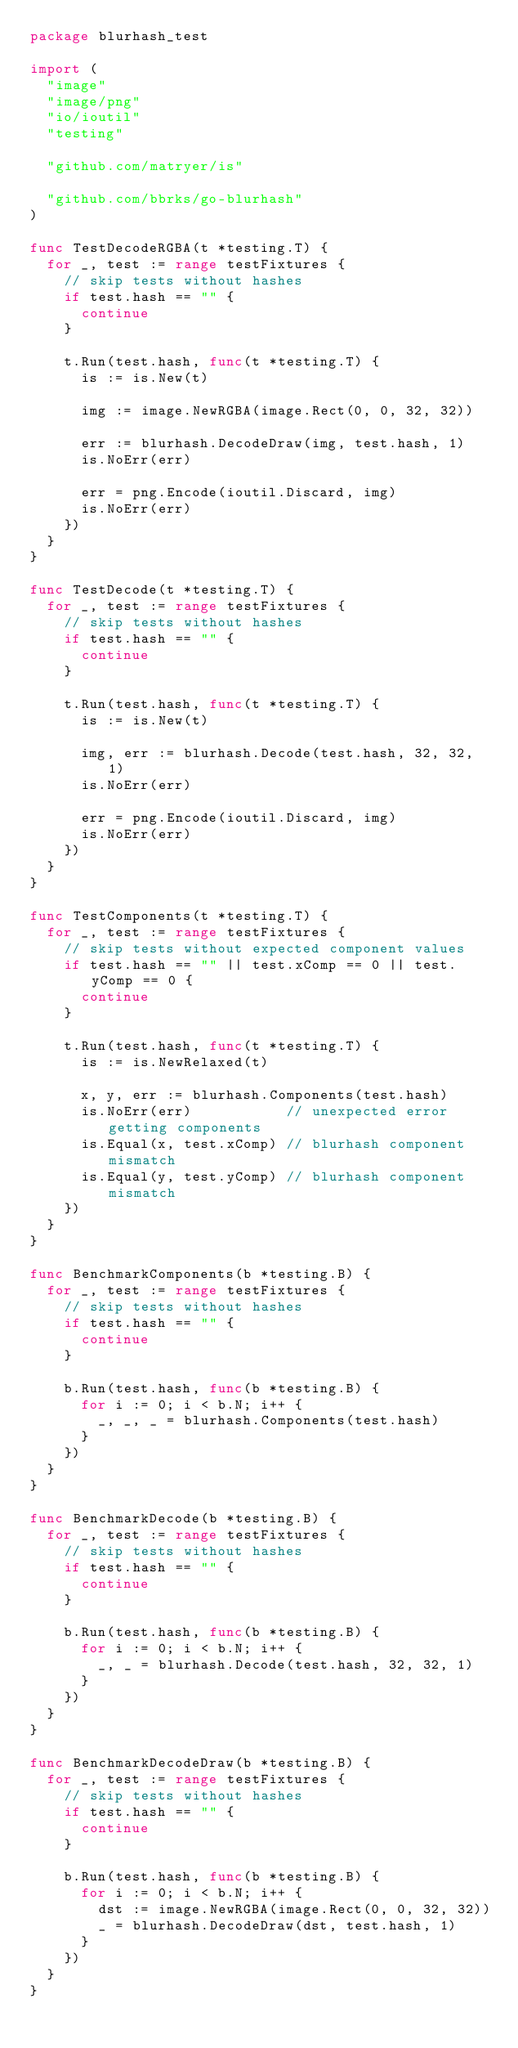<code> <loc_0><loc_0><loc_500><loc_500><_Go_>package blurhash_test

import (
	"image"
	"image/png"
	"io/ioutil"
	"testing"

	"github.com/matryer/is"

	"github.com/bbrks/go-blurhash"
)

func TestDecodeRGBA(t *testing.T) {
	for _, test := range testFixtures {
		// skip tests without hashes
		if test.hash == "" {
			continue
		}

		t.Run(test.hash, func(t *testing.T) {
			is := is.New(t)

			img := image.NewRGBA(image.Rect(0, 0, 32, 32))

			err := blurhash.DecodeDraw(img, test.hash, 1)
			is.NoErr(err)

			err = png.Encode(ioutil.Discard, img)
			is.NoErr(err)
		})
	}
}

func TestDecode(t *testing.T) {
	for _, test := range testFixtures {
		// skip tests without hashes
		if test.hash == "" {
			continue
		}

		t.Run(test.hash, func(t *testing.T) {
			is := is.New(t)

			img, err := blurhash.Decode(test.hash, 32, 32, 1)
			is.NoErr(err)

			err = png.Encode(ioutil.Discard, img)
			is.NoErr(err)
		})
	}
}

func TestComponents(t *testing.T) {
	for _, test := range testFixtures {
		// skip tests without expected component values
		if test.hash == "" || test.xComp == 0 || test.yComp == 0 {
			continue
		}

		t.Run(test.hash, func(t *testing.T) {
			is := is.NewRelaxed(t)

			x, y, err := blurhash.Components(test.hash)
			is.NoErr(err)           // unexpected error getting components
			is.Equal(x, test.xComp) // blurhash component mismatch
			is.Equal(y, test.yComp) // blurhash component mismatch
		})
	}
}

func BenchmarkComponents(b *testing.B) {
	for _, test := range testFixtures {
		// skip tests without hashes
		if test.hash == "" {
			continue
		}

		b.Run(test.hash, func(b *testing.B) {
			for i := 0; i < b.N; i++ {
				_, _, _ = blurhash.Components(test.hash)
			}
		})
	}
}

func BenchmarkDecode(b *testing.B) {
	for _, test := range testFixtures {
		// skip tests without hashes
		if test.hash == "" {
			continue
		}

		b.Run(test.hash, func(b *testing.B) {
			for i := 0; i < b.N; i++ {
				_, _ = blurhash.Decode(test.hash, 32, 32, 1)
			}
		})
	}
}

func BenchmarkDecodeDraw(b *testing.B) {
	for _, test := range testFixtures {
		// skip tests without hashes
		if test.hash == "" {
			continue
		}

		b.Run(test.hash, func(b *testing.B) {
			for i := 0; i < b.N; i++ {
				dst := image.NewRGBA(image.Rect(0, 0, 32, 32))
				_ = blurhash.DecodeDraw(dst, test.hash, 1)
			}
		})
	}
}
</code> 